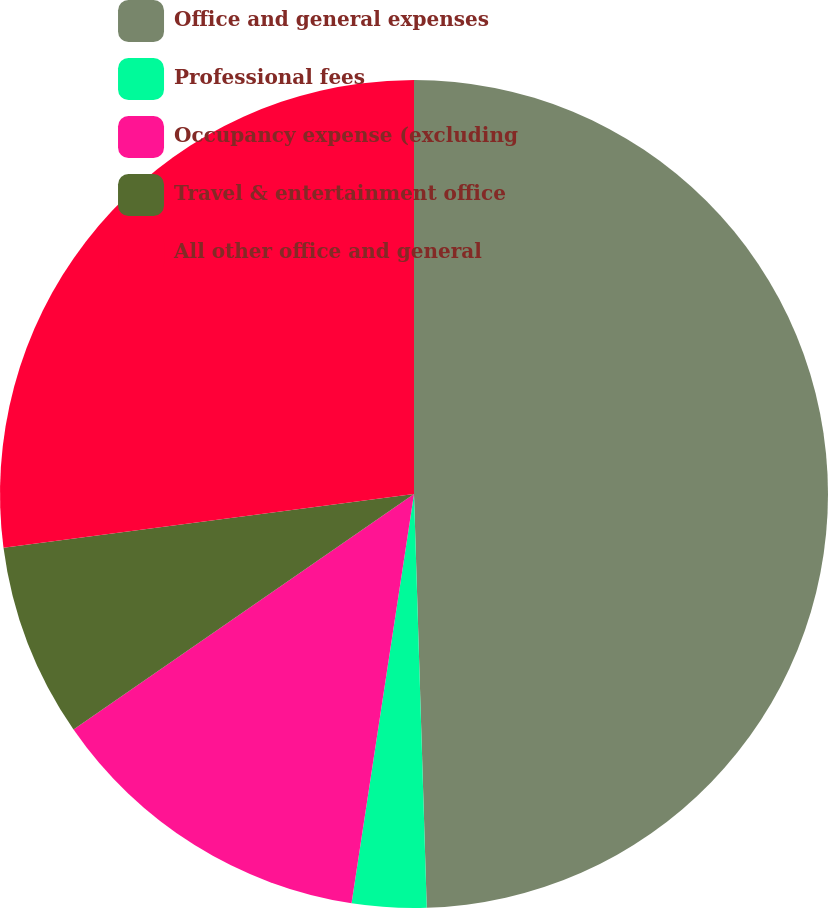Convert chart. <chart><loc_0><loc_0><loc_500><loc_500><pie_chart><fcel>Office and general expenses<fcel>Professional fees<fcel>Occupancy expense (excluding<fcel>Travel & entertainment office<fcel>All other office and general<nl><fcel>49.51%<fcel>2.9%<fcel>12.96%<fcel>7.56%<fcel>27.07%<nl></chart> 